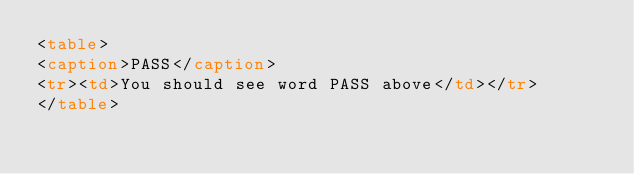Convert code to text. <code><loc_0><loc_0><loc_500><loc_500><_HTML_><table>
<caption>PASS</caption>
<tr><td>You should see word PASS above</td></tr>
</table>
</code> 